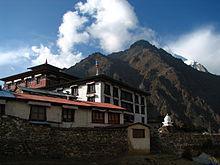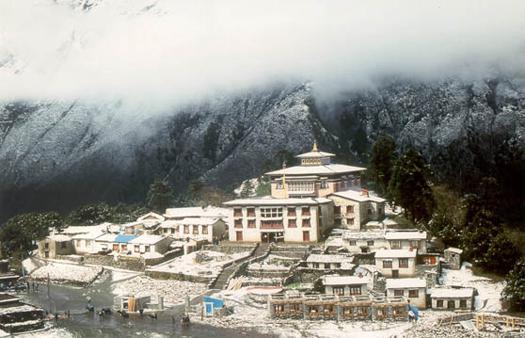The first image is the image on the left, the second image is the image on the right. Considering the images on both sides, is "In the right image, a neutral colored building with at least eight windows on its front is on a hillside with mountains in the background." valid? Answer yes or no. Yes. The first image is the image on the left, the second image is the image on the right. Considering the images on both sides, is "People are standing outside of the building in the image on the right." valid? Answer yes or no. No. 